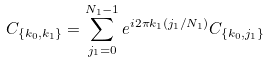Convert formula to latex. <formula><loc_0><loc_0><loc_500><loc_500>C _ { \{ k _ { 0 } , k _ { 1 } \} } = \sum _ { j _ { 1 } = 0 } ^ { N _ { 1 } - 1 } e ^ { i 2 \pi k _ { 1 } ( j _ { 1 } / N _ { 1 } ) } C _ { \{ k _ { 0 } , j _ { 1 } \} }</formula> 